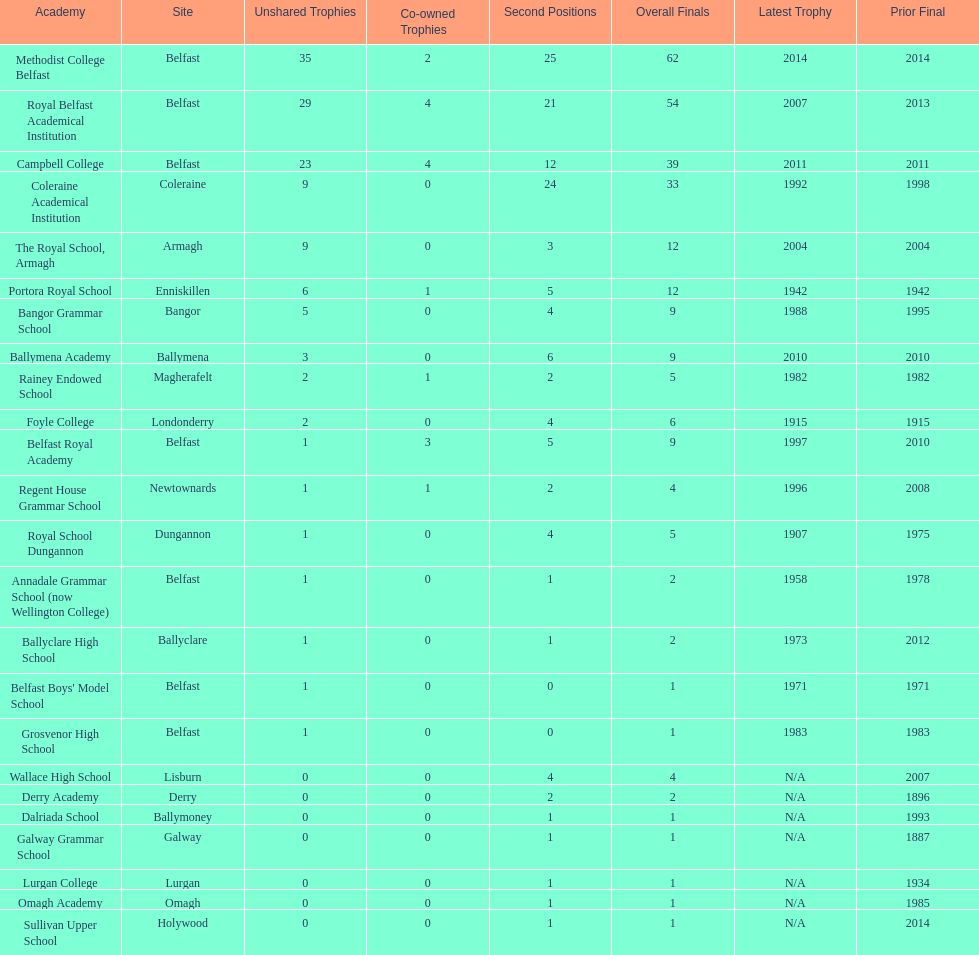How many schools have had at least 3 share titles? 3. 